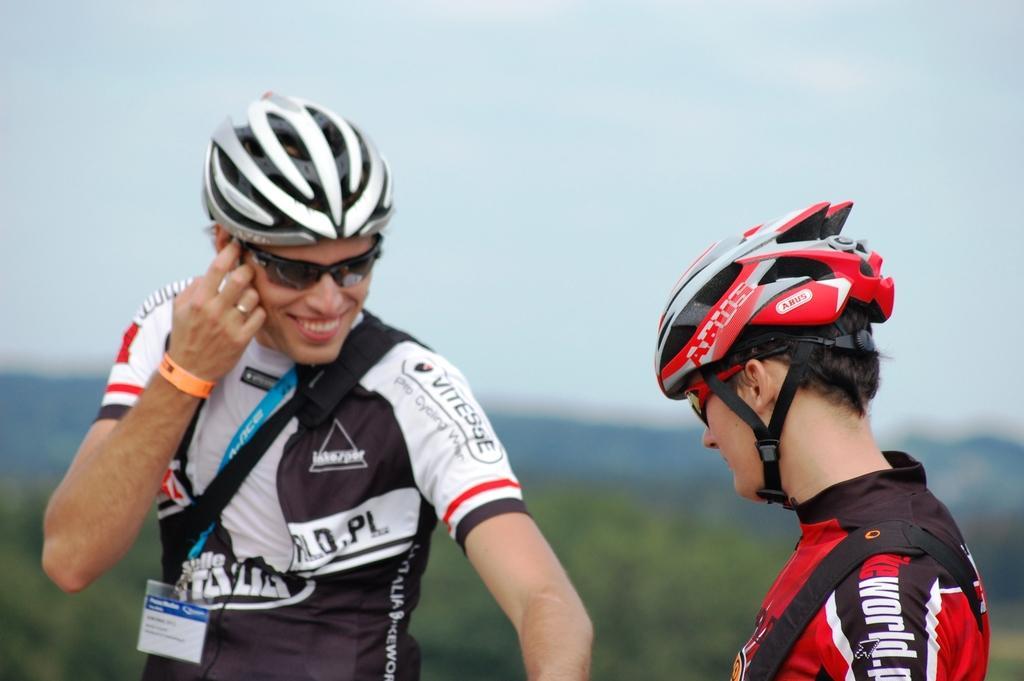Please provide a concise description of this image. In this image we can see two persons. A person is wearing an identity card in the image. There is a sky in the image. There are many trees in the image. 